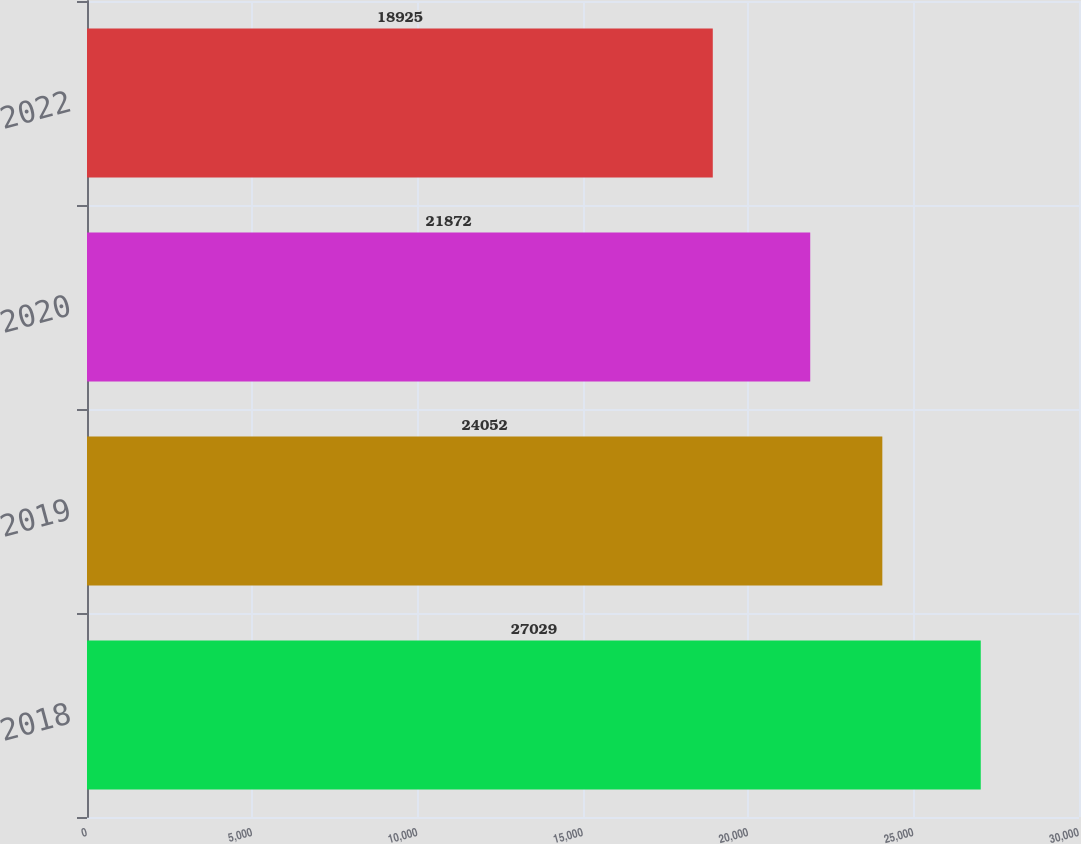Convert chart to OTSL. <chart><loc_0><loc_0><loc_500><loc_500><bar_chart><fcel>2018<fcel>2019<fcel>2020<fcel>2022<nl><fcel>27029<fcel>24052<fcel>21872<fcel>18925<nl></chart> 